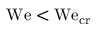<formula> <loc_0><loc_0><loc_500><loc_500>W e < W e _ { c r }</formula> 